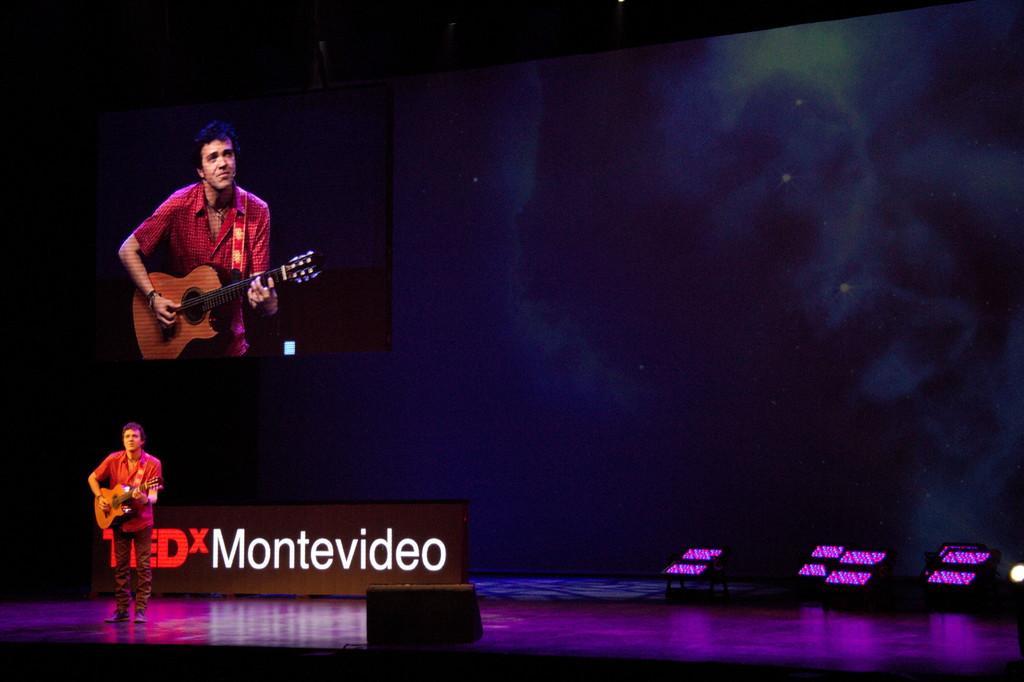In one or two sentences, can you explain what this image depicts? in this picture we can see a man holding guitar in his hand and playing it and standing on stage and in the background we can see screen of same person, wall, lights. 